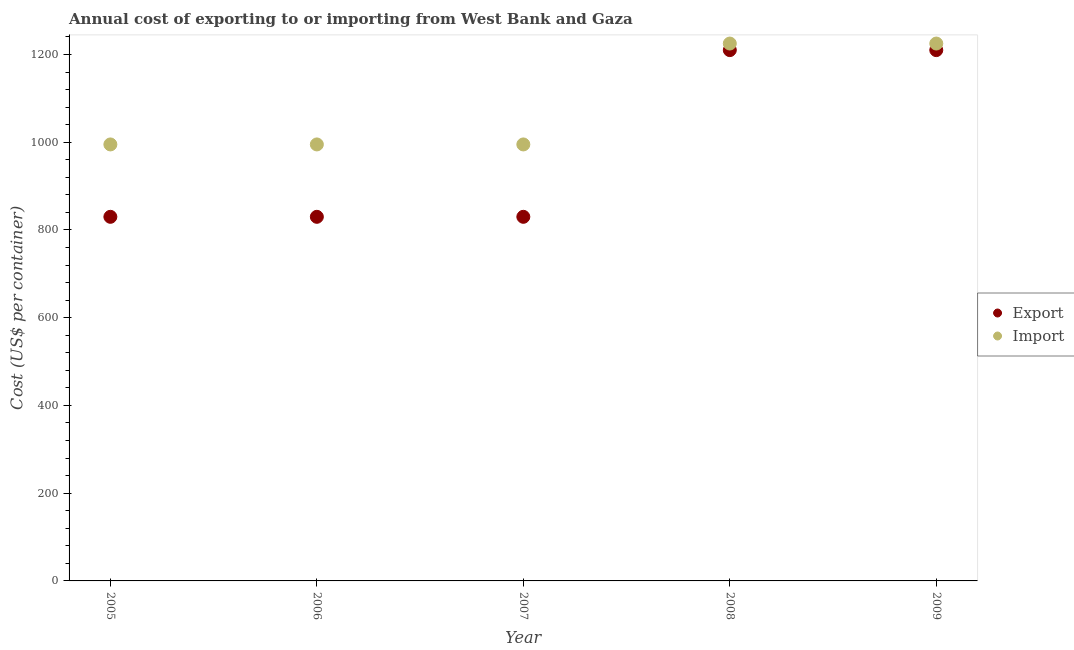Is the number of dotlines equal to the number of legend labels?
Provide a succinct answer. Yes. What is the import cost in 2008?
Give a very brief answer. 1225. Across all years, what is the maximum import cost?
Give a very brief answer. 1225. Across all years, what is the minimum export cost?
Keep it short and to the point. 830. In which year was the import cost maximum?
Your answer should be very brief. 2008. In which year was the import cost minimum?
Your response must be concise. 2005. What is the total import cost in the graph?
Ensure brevity in your answer.  5435. What is the difference between the export cost in 2007 and the import cost in 2005?
Your response must be concise. -165. What is the average import cost per year?
Provide a succinct answer. 1087. In the year 2006, what is the difference between the import cost and export cost?
Provide a succinct answer. 165. In how many years, is the export cost greater than 1000 US$?
Ensure brevity in your answer.  2. Is the export cost in 2008 less than that in 2009?
Offer a terse response. No. Is the difference between the import cost in 2005 and 2008 greater than the difference between the export cost in 2005 and 2008?
Your answer should be compact. Yes. What is the difference between the highest and the lowest import cost?
Offer a very short reply. 230. Is the sum of the import cost in 2007 and 2008 greater than the maximum export cost across all years?
Keep it short and to the point. Yes. Does the export cost monotonically increase over the years?
Ensure brevity in your answer.  No. Is the export cost strictly less than the import cost over the years?
Provide a succinct answer. Yes. How many years are there in the graph?
Your answer should be very brief. 5. Are the values on the major ticks of Y-axis written in scientific E-notation?
Offer a terse response. No. Does the graph contain any zero values?
Your response must be concise. No. Does the graph contain grids?
Your answer should be very brief. No. How many legend labels are there?
Give a very brief answer. 2. How are the legend labels stacked?
Provide a succinct answer. Vertical. What is the title of the graph?
Your response must be concise. Annual cost of exporting to or importing from West Bank and Gaza. What is the label or title of the Y-axis?
Make the answer very short. Cost (US$ per container). What is the Cost (US$ per container) in Export in 2005?
Provide a short and direct response. 830. What is the Cost (US$ per container) of Import in 2005?
Make the answer very short. 995. What is the Cost (US$ per container) of Export in 2006?
Ensure brevity in your answer.  830. What is the Cost (US$ per container) of Import in 2006?
Your response must be concise. 995. What is the Cost (US$ per container) of Export in 2007?
Offer a very short reply. 830. What is the Cost (US$ per container) in Import in 2007?
Provide a short and direct response. 995. What is the Cost (US$ per container) in Export in 2008?
Your response must be concise. 1210. What is the Cost (US$ per container) of Import in 2008?
Provide a succinct answer. 1225. What is the Cost (US$ per container) of Export in 2009?
Your response must be concise. 1210. What is the Cost (US$ per container) of Import in 2009?
Give a very brief answer. 1225. Across all years, what is the maximum Cost (US$ per container) in Export?
Your answer should be very brief. 1210. Across all years, what is the maximum Cost (US$ per container) of Import?
Offer a very short reply. 1225. Across all years, what is the minimum Cost (US$ per container) in Export?
Ensure brevity in your answer.  830. Across all years, what is the minimum Cost (US$ per container) in Import?
Provide a short and direct response. 995. What is the total Cost (US$ per container) in Export in the graph?
Your answer should be very brief. 4910. What is the total Cost (US$ per container) of Import in the graph?
Provide a succinct answer. 5435. What is the difference between the Cost (US$ per container) in Export in 2005 and that in 2006?
Make the answer very short. 0. What is the difference between the Cost (US$ per container) of Import in 2005 and that in 2007?
Your answer should be very brief. 0. What is the difference between the Cost (US$ per container) of Export in 2005 and that in 2008?
Provide a short and direct response. -380. What is the difference between the Cost (US$ per container) in Import in 2005 and that in 2008?
Make the answer very short. -230. What is the difference between the Cost (US$ per container) in Export in 2005 and that in 2009?
Your response must be concise. -380. What is the difference between the Cost (US$ per container) of Import in 2005 and that in 2009?
Provide a succinct answer. -230. What is the difference between the Cost (US$ per container) of Export in 2006 and that in 2007?
Give a very brief answer. 0. What is the difference between the Cost (US$ per container) of Export in 2006 and that in 2008?
Provide a succinct answer. -380. What is the difference between the Cost (US$ per container) of Import in 2006 and that in 2008?
Your answer should be very brief. -230. What is the difference between the Cost (US$ per container) in Export in 2006 and that in 2009?
Keep it short and to the point. -380. What is the difference between the Cost (US$ per container) in Import in 2006 and that in 2009?
Keep it short and to the point. -230. What is the difference between the Cost (US$ per container) of Export in 2007 and that in 2008?
Give a very brief answer. -380. What is the difference between the Cost (US$ per container) in Import in 2007 and that in 2008?
Give a very brief answer. -230. What is the difference between the Cost (US$ per container) of Export in 2007 and that in 2009?
Provide a short and direct response. -380. What is the difference between the Cost (US$ per container) of Import in 2007 and that in 2009?
Your answer should be compact. -230. What is the difference between the Cost (US$ per container) of Export in 2008 and that in 2009?
Your answer should be compact. 0. What is the difference between the Cost (US$ per container) of Import in 2008 and that in 2009?
Your answer should be very brief. 0. What is the difference between the Cost (US$ per container) in Export in 2005 and the Cost (US$ per container) in Import in 2006?
Ensure brevity in your answer.  -165. What is the difference between the Cost (US$ per container) of Export in 2005 and the Cost (US$ per container) of Import in 2007?
Your answer should be very brief. -165. What is the difference between the Cost (US$ per container) in Export in 2005 and the Cost (US$ per container) in Import in 2008?
Give a very brief answer. -395. What is the difference between the Cost (US$ per container) in Export in 2005 and the Cost (US$ per container) in Import in 2009?
Your answer should be compact. -395. What is the difference between the Cost (US$ per container) of Export in 2006 and the Cost (US$ per container) of Import in 2007?
Provide a short and direct response. -165. What is the difference between the Cost (US$ per container) of Export in 2006 and the Cost (US$ per container) of Import in 2008?
Keep it short and to the point. -395. What is the difference between the Cost (US$ per container) of Export in 2006 and the Cost (US$ per container) of Import in 2009?
Make the answer very short. -395. What is the difference between the Cost (US$ per container) of Export in 2007 and the Cost (US$ per container) of Import in 2008?
Provide a short and direct response. -395. What is the difference between the Cost (US$ per container) of Export in 2007 and the Cost (US$ per container) of Import in 2009?
Offer a very short reply. -395. What is the average Cost (US$ per container) of Export per year?
Keep it short and to the point. 982. What is the average Cost (US$ per container) in Import per year?
Give a very brief answer. 1087. In the year 2005, what is the difference between the Cost (US$ per container) in Export and Cost (US$ per container) in Import?
Give a very brief answer. -165. In the year 2006, what is the difference between the Cost (US$ per container) in Export and Cost (US$ per container) in Import?
Keep it short and to the point. -165. In the year 2007, what is the difference between the Cost (US$ per container) in Export and Cost (US$ per container) in Import?
Offer a terse response. -165. In the year 2008, what is the difference between the Cost (US$ per container) of Export and Cost (US$ per container) of Import?
Give a very brief answer. -15. In the year 2009, what is the difference between the Cost (US$ per container) of Export and Cost (US$ per container) of Import?
Keep it short and to the point. -15. What is the ratio of the Cost (US$ per container) of Export in 2005 to that in 2007?
Your response must be concise. 1. What is the ratio of the Cost (US$ per container) in Export in 2005 to that in 2008?
Your response must be concise. 0.69. What is the ratio of the Cost (US$ per container) in Import in 2005 to that in 2008?
Offer a terse response. 0.81. What is the ratio of the Cost (US$ per container) of Export in 2005 to that in 2009?
Your answer should be very brief. 0.69. What is the ratio of the Cost (US$ per container) of Import in 2005 to that in 2009?
Your answer should be compact. 0.81. What is the ratio of the Cost (US$ per container) of Import in 2006 to that in 2007?
Offer a very short reply. 1. What is the ratio of the Cost (US$ per container) of Export in 2006 to that in 2008?
Your answer should be very brief. 0.69. What is the ratio of the Cost (US$ per container) of Import in 2006 to that in 2008?
Keep it short and to the point. 0.81. What is the ratio of the Cost (US$ per container) in Export in 2006 to that in 2009?
Your answer should be very brief. 0.69. What is the ratio of the Cost (US$ per container) in Import in 2006 to that in 2009?
Offer a terse response. 0.81. What is the ratio of the Cost (US$ per container) of Export in 2007 to that in 2008?
Your response must be concise. 0.69. What is the ratio of the Cost (US$ per container) of Import in 2007 to that in 2008?
Provide a short and direct response. 0.81. What is the ratio of the Cost (US$ per container) of Export in 2007 to that in 2009?
Provide a succinct answer. 0.69. What is the ratio of the Cost (US$ per container) of Import in 2007 to that in 2009?
Provide a short and direct response. 0.81. What is the ratio of the Cost (US$ per container) of Export in 2008 to that in 2009?
Offer a terse response. 1. What is the difference between the highest and the second highest Cost (US$ per container) of Export?
Provide a short and direct response. 0. What is the difference between the highest and the lowest Cost (US$ per container) of Export?
Provide a short and direct response. 380. What is the difference between the highest and the lowest Cost (US$ per container) of Import?
Keep it short and to the point. 230. 